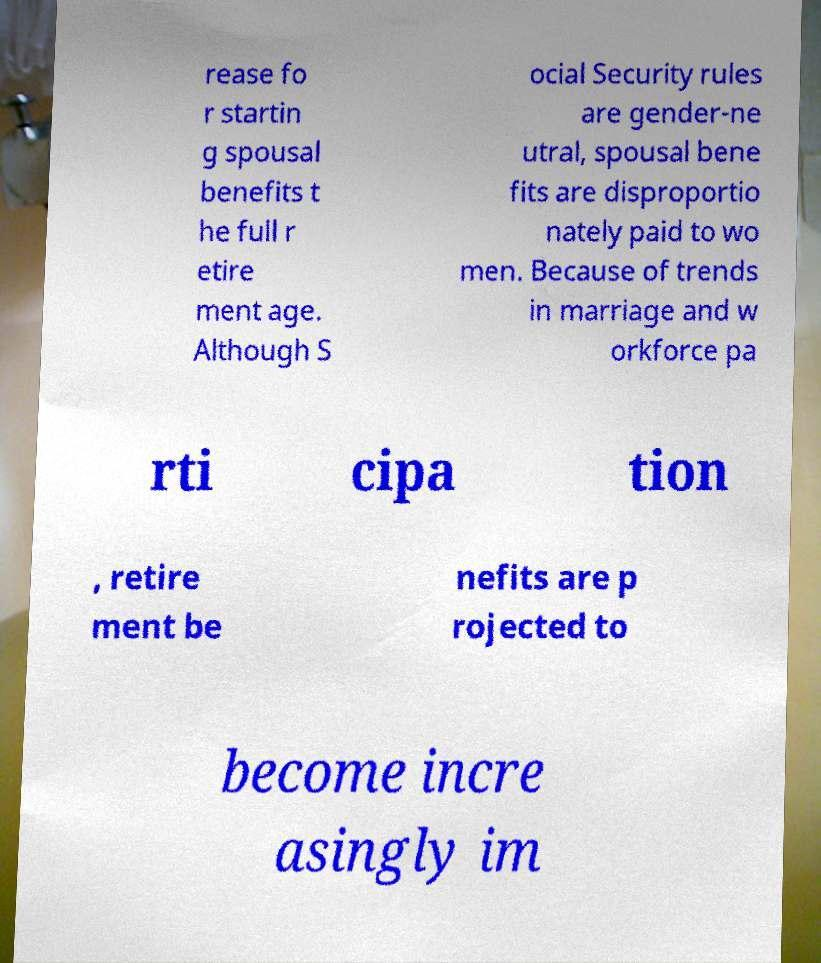Please identify and transcribe the text found in this image. rease fo r startin g spousal benefits t he full r etire ment age. Although S ocial Security rules are gender-ne utral, spousal bene fits are disproportio nately paid to wo men. Because of trends in marriage and w orkforce pa rti cipa tion , retire ment be nefits are p rojected to become incre asingly im 